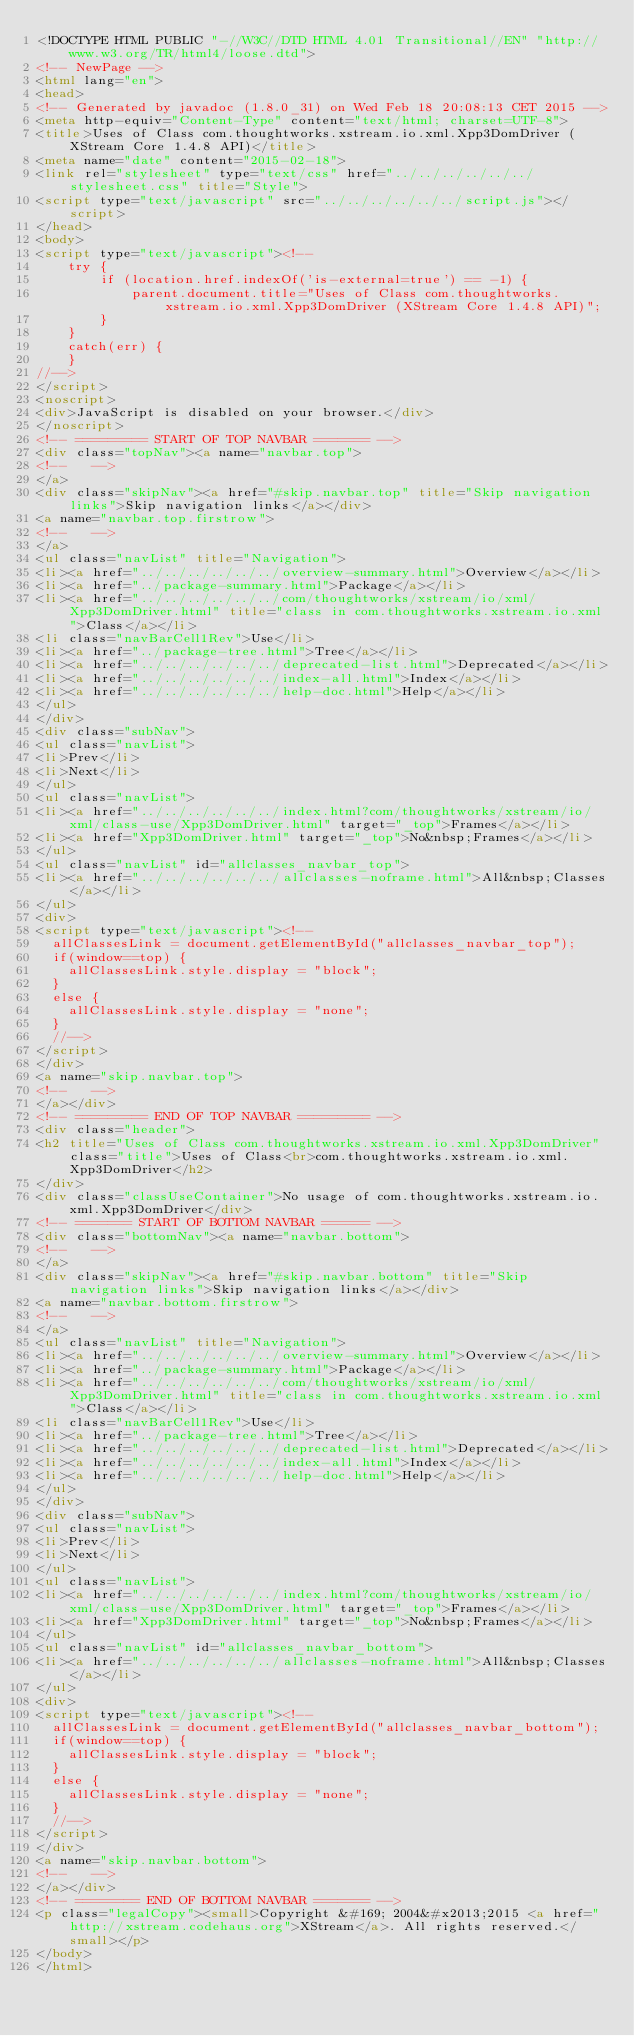Convert code to text. <code><loc_0><loc_0><loc_500><loc_500><_HTML_><!DOCTYPE HTML PUBLIC "-//W3C//DTD HTML 4.01 Transitional//EN" "http://www.w3.org/TR/html4/loose.dtd">
<!-- NewPage -->
<html lang="en">
<head>
<!-- Generated by javadoc (1.8.0_31) on Wed Feb 18 20:08:13 CET 2015 -->
<meta http-equiv="Content-Type" content="text/html; charset=UTF-8">
<title>Uses of Class com.thoughtworks.xstream.io.xml.Xpp3DomDriver (XStream Core 1.4.8 API)</title>
<meta name="date" content="2015-02-18">
<link rel="stylesheet" type="text/css" href="../../../../../../stylesheet.css" title="Style">
<script type="text/javascript" src="../../../../../../script.js"></script>
</head>
<body>
<script type="text/javascript"><!--
    try {
        if (location.href.indexOf('is-external=true') == -1) {
            parent.document.title="Uses of Class com.thoughtworks.xstream.io.xml.Xpp3DomDriver (XStream Core 1.4.8 API)";
        }
    }
    catch(err) {
    }
//-->
</script>
<noscript>
<div>JavaScript is disabled on your browser.</div>
</noscript>
<!-- ========= START OF TOP NAVBAR ======= -->
<div class="topNav"><a name="navbar.top">
<!--   -->
</a>
<div class="skipNav"><a href="#skip.navbar.top" title="Skip navigation links">Skip navigation links</a></div>
<a name="navbar.top.firstrow">
<!--   -->
</a>
<ul class="navList" title="Navigation">
<li><a href="../../../../../../overview-summary.html">Overview</a></li>
<li><a href="../package-summary.html">Package</a></li>
<li><a href="../../../../../../com/thoughtworks/xstream/io/xml/Xpp3DomDriver.html" title="class in com.thoughtworks.xstream.io.xml">Class</a></li>
<li class="navBarCell1Rev">Use</li>
<li><a href="../package-tree.html">Tree</a></li>
<li><a href="../../../../../../deprecated-list.html">Deprecated</a></li>
<li><a href="../../../../../../index-all.html">Index</a></li>
<li><a href="../../../../../../help-doc.html">Help</a></li>
</ul>
</div>
<div class="subNav">
<ul class="navList">
<li>Prev</li>
<li>Next</li>
</ul>
<ul class="navList">
<li><a href="../../../../../../index.html?com/thoughtworks/xstream/io/xml/class-use/Xpp3DomDriver.html" target="_top">Frames</a></li>
<li><a href="Xpp3DomDriver.html" target="_top">No&nbsp;Frames</a></li>
</ul>
<ul class="navList" id="allclasses_navbar_top">
<li><a href="../../../../../../allclasses-noframe.html">All&nbsp;Classes</a></li>
</ul>
<div>
<script type="text/javascript"><!--
  allClassesLink = document.getElementById("allclasses_navbar_top");
  if(window==top) {
    allClassesLink.style.display = "block";
  }
  else {
    allClassesLink.style.display = "none";
  }
  //-->
</script>
</div>
<a name="skip.navbar.top">
<!--   -->
</a></div>
<!-- ========= END OF TOP NAVBAR ========= -->
<div class="header">
<h2 title="Uses of Class com.thoughtworks.xstream.io.xml.Xpp3DomDriver" class="title">Uses of Class<br>com.thoughtworks.xstream.io.xml.Xpp3DomDriver</h2>
</div>
<div class="classUseContainer">No usage of com.thoughtworks.xstream.io.xml.Xpp3DomDriver</div>
<!-- ======= START OF BOTTOM NAVBAR ====== -->
<div class="bottomNav"><a name="navbar.bottom">
<!--   -->
</a>
<div class="skipNav"><a href="#skip.navbar.bottom" title="Skip navigation links">Skip navigation links</a></div>
<a name="navbar.bottom.firstrow">
<!--   -->
</a>
<ul class="navList" title="Navigation">
<li><a href="../../../../../../overview-summary.html">Overview</a></li>
<li><a href="../package-summary.html">Package</a></li>
<li><a href="../../../../../../com/thoughtworks/xstream/io/xml/Xpp3DomDriver.html" title="class in com.thoughtworks.xstream.io.xml">Class</a></li>
<li class="navBarCell1Rev">Use</li>
<li><a href="../package-tree.html">Tree</a></li>
<li><a href="../../../../../../deprecated-list.html">Deprecated</a></li>
<li><a href="../../../../../../index-all.html">Index</a></li>
<li><a href="../../../../../../help-doc.html">Help</a></li>
</ul>
</div>
<div class="subNav">
<ul class="navList">
<li>Prev</li>
<li>Next</li>
</ul>
<ul class="navList">
<li><a href="../../../../../../index.html?com/thoughtworks/xstream/io/xml/class-use/Xpp3DomDriver.html" target="_top">Frames</a></li>
<li><a href="Xpp3DomDriver.html" target="_top">No&nbsp;Frames</a></li>
</ul>
<ul class="navList" id="allclasses_navbar_bottom">
<li><a href="../../../../../../allclasses-noframe.html">All&nbsp;Classes</a></li>
</ul>
<div>
<script type="text/javascript"><!--
  allClassesLink = document.getElementById("allclasses_navbar_bottom");
  if(window==top) {
    allClassesLink.style.display = "block";
  }
  else {
    allClassesLink.style.display = "none";
  }
  //-->
</script>
</div>
<a name="skip.navbar.bottom">
<!--   -->
</a></div>
<!-- ======== END OF BOTTOM NAVBAR ======= -->
<p class="legalCopy"><small>Copyright &#169; 2004&#x2013;2015 <a href="http://xstream.codehaus.org">XStream</a>. All rights reserved.</small></p>
</body>
</html>
</code> 